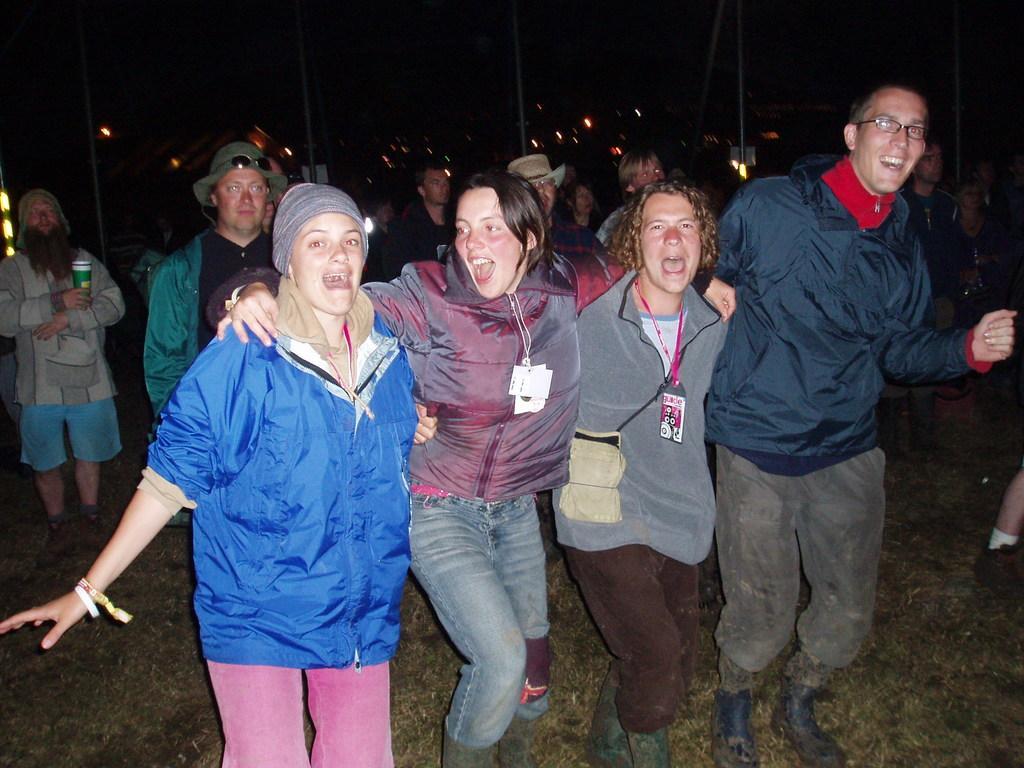Could you give a brief overview of what you see in this image? In this image we can see many people. Some are wearing specs. Some are wearing hats. And some people are wearing tags. On the ground there is grass. In the background there are lights. And it is looking dark. And also there are poles. 